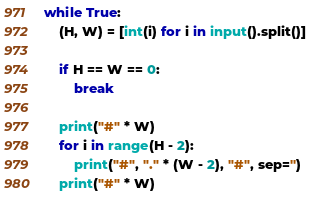<code> <loc_0><loc_0><loc_500><loc_500><_Python_>while True:
    (H, W) = [int(i) for i in input().split()]

    if H == W == 0:
        break

    print("#" * W)
    for i in range(H - 2):
        print("#", "." * (W - 2), "#", sep='')
    print("#" * W)</code> 